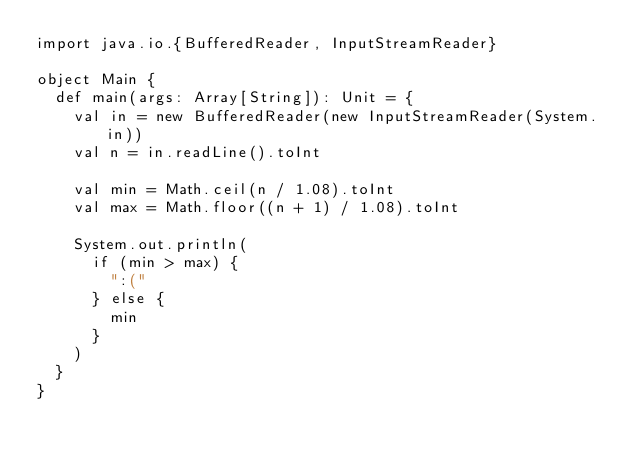<code> <loc_0><loc_0><loc_500><loc_500><_Scala_>import java.io.{BufferedReader, InputStreamReader}

object Main {
  def main(args: Array[String]): Unit = {
    val in = new BufferedReader(new InputStreamReader(System.in))
    val n = in.readLine().toInt

    val min = Math.ceil(n / 1.08).toInt
    val max = Math.floor((n + 1) / 1.08).toInt

    System.out.println(
      if (min > max) {
        ":("
      } else {
        min
      }
    )
  }
}
</code> 